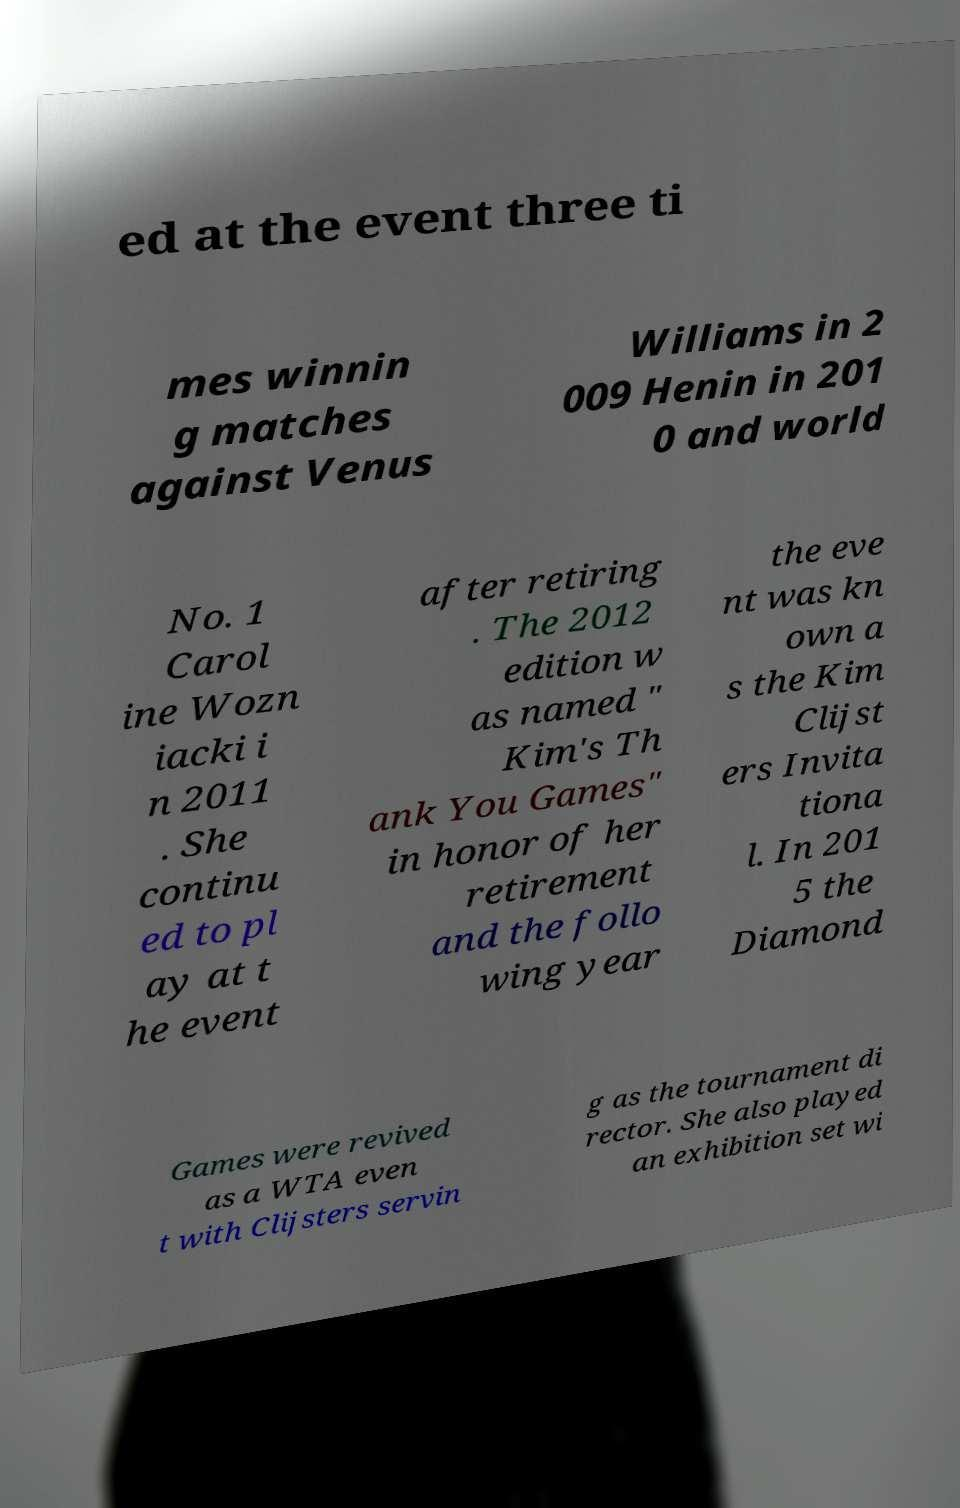There's text embedded in this image that I need extracted. Can you transcribe it verbatim? ed at the event three ti mes winnin g matches against Venus Williams in 2 009 Henin in 201 0 and world No. 1 Carol ine Wozn iacki i n 2011 . She continu ed to pl ay at t he event after retiring . The 2012 edition w as named " Kim's Th ank You Games" in honor of her retirement and the follo wing year the eve nt was kn own a s the Kim Clijst ers Invita tiona l. In 201 5 the Diamond Games were revived as a WTA even t with Clijsters servin g as the tournament di rector. She also played an exhibition set wi 